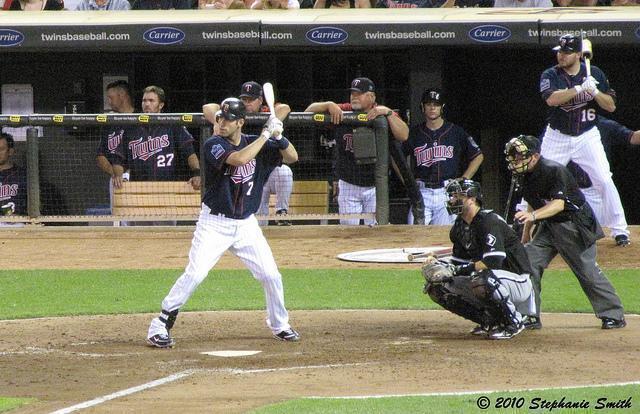What league does the team with the standing players play in?
Choose the correct response, then elucidate: 'Answer: answer
Rationale: rationale.'
Options: Nfc south, afc east, american league, national league. Answer: american league.
Rationale: The minnesota twins baseball team are batting. they do not play in the national league. 